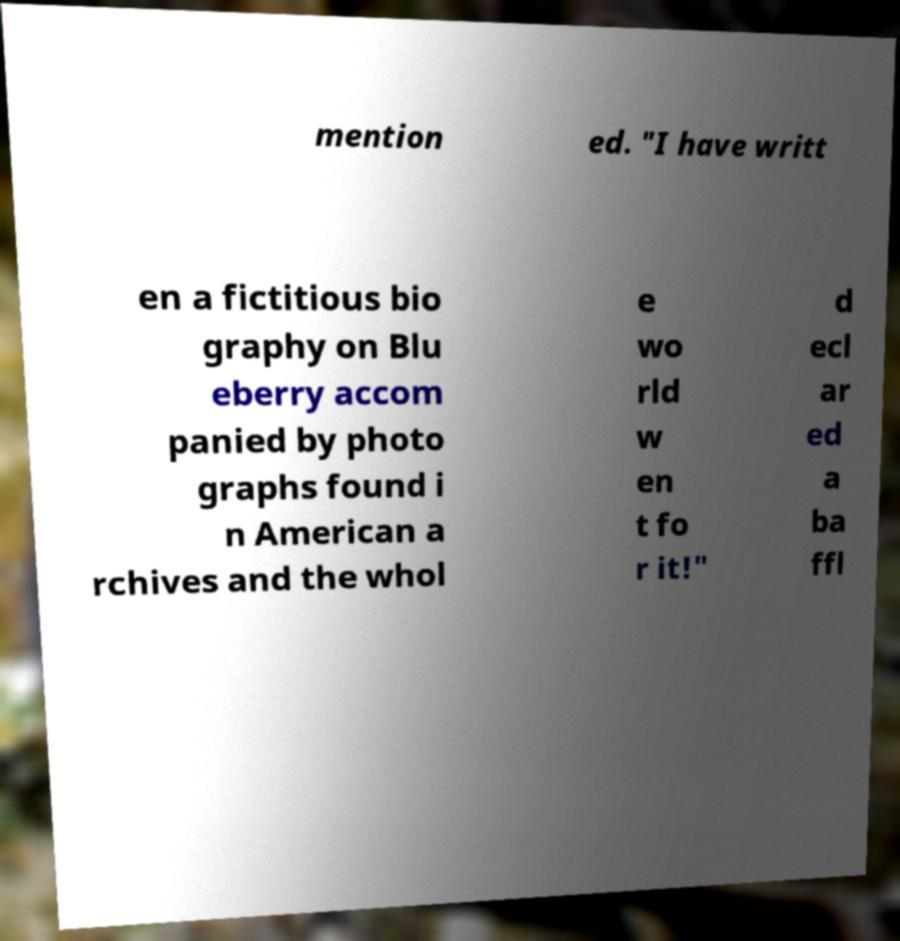For documentation purposes, I need the text within this image transcribed. Could you provide that? mention ed. "I have writt en a fictitious bio graphy on Blu eberry accom panied by photo graphs found i n American a rchives and the whol e wo rld w en t fo r it!" d ecl ar ed a ba ffl 